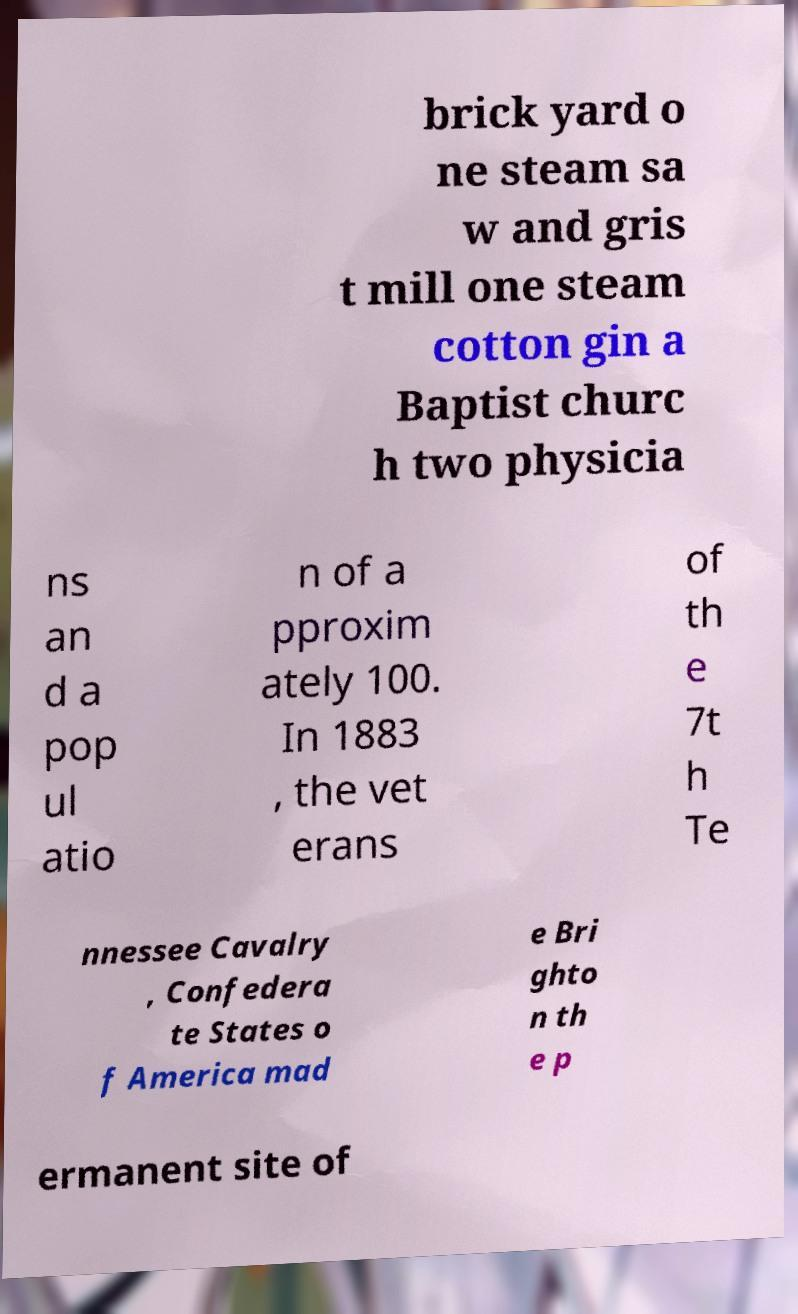Could you assist in decoding the text presented in this image and type it out clearly? brick yard o ne steam sa w and gris t mill one steam cotton gin a Baptist churc h two physicia ns an d a pop ul atio n of a pproxim ately 100. In 1883 , the vet erans of th e 7t h Te nnessee Cavalry , Confedera te States o f America mad e Bri ghto n th e p ermanent site of 